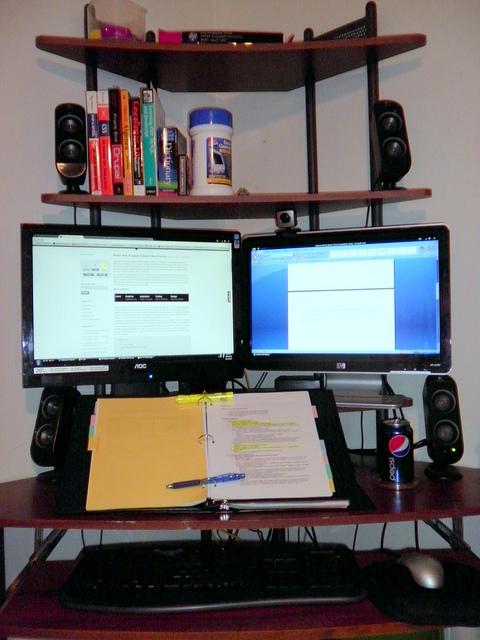How many monitors are on the desk?
Short answer required. 2. What is on the table above the keyboard?
Give a very brief answer. Binder. What type of soda is shown?
Write a very short answer. Pepsi. Are there speakers above the monitors?
Answer briefly. Yes. How many shelves are there?
Keep it brief. 3. Are the monitors the same size?
Be succinct. No. 